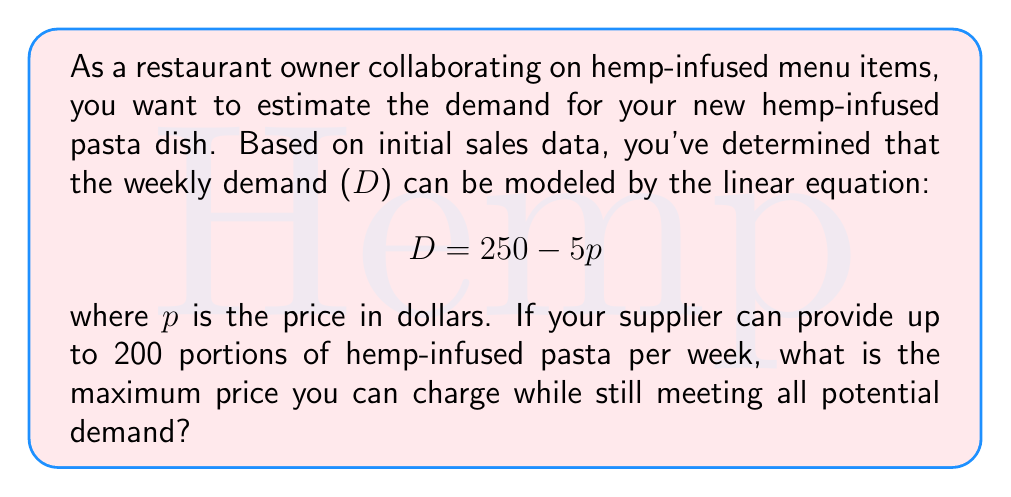Show me your answer to this math problem. To solve this problem, we need to follow these steps:

1) The demand equation is given as $D = 250 - 5p$, where $D$ is the weekly demand and $p$ is the price in dollars.

2) We know that the supplier can provide up to 200 portions per week. This means we need to find the price at which the demand equals 200:

   $$ 200 = 250 - 5p $$

3) Now we can solve this equation for $p$:
   
   $$ 200 - 250 = -5p $$
   $$ -50 = -5p $$
   $$ p = \frac{50}{5} = 10 $$

4) We can verify this by plugging $p = 10$ back into the original equation:

   $$ D = 250 - 5(10) = 250 - 50 = 200 $$

5) This price of $10 ensures that demand will be exactly 200, which matches the maximum supply. Any price lower than $10 would create a demand higher than 200, which cannot be met by the supplier.

Therefore, the maximum price you can charge while still meeting all potential demand is $10.
Answer: $10 